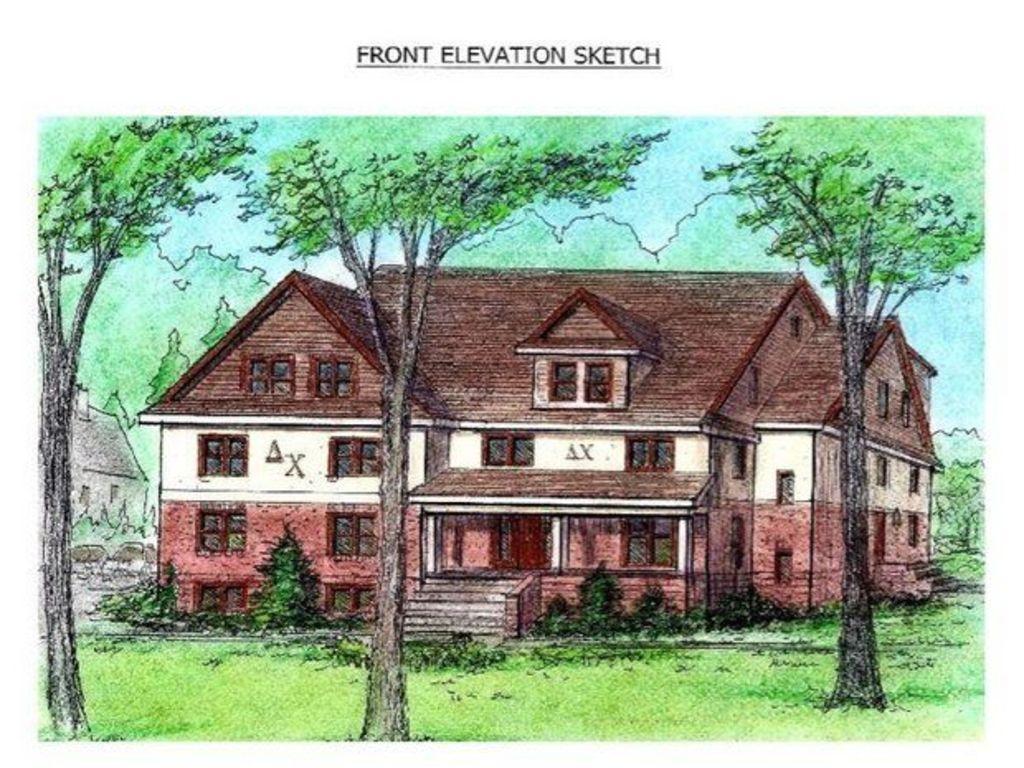Could you give a brief overview of what you see in this image? There is a drawing of trees, grass and a building which has stairs, door and windows. 